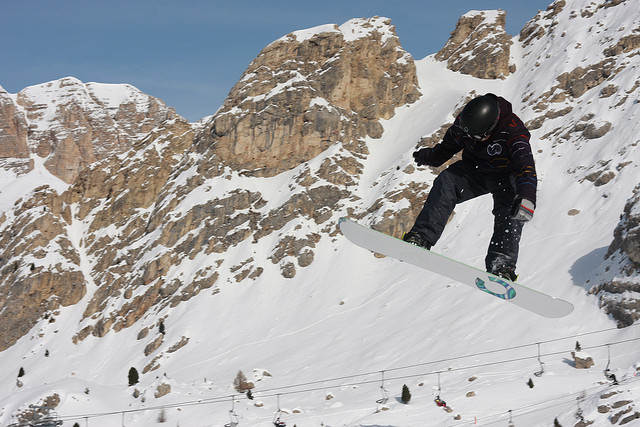Can you discuss the probable skill level of the snowboarder based on the image? Based on the image, which captures the snowboarder in mid-air against the backdrop of a challenging mountainous terrain, it can be inferred that the snowboarder possesses significant skill and experience. The airborne maneuver and confident posture suggest a high level of proficiency in snowboarding. The choice of equipment and terrain further supports the inference of the snowboarder’s advanced skill level. 